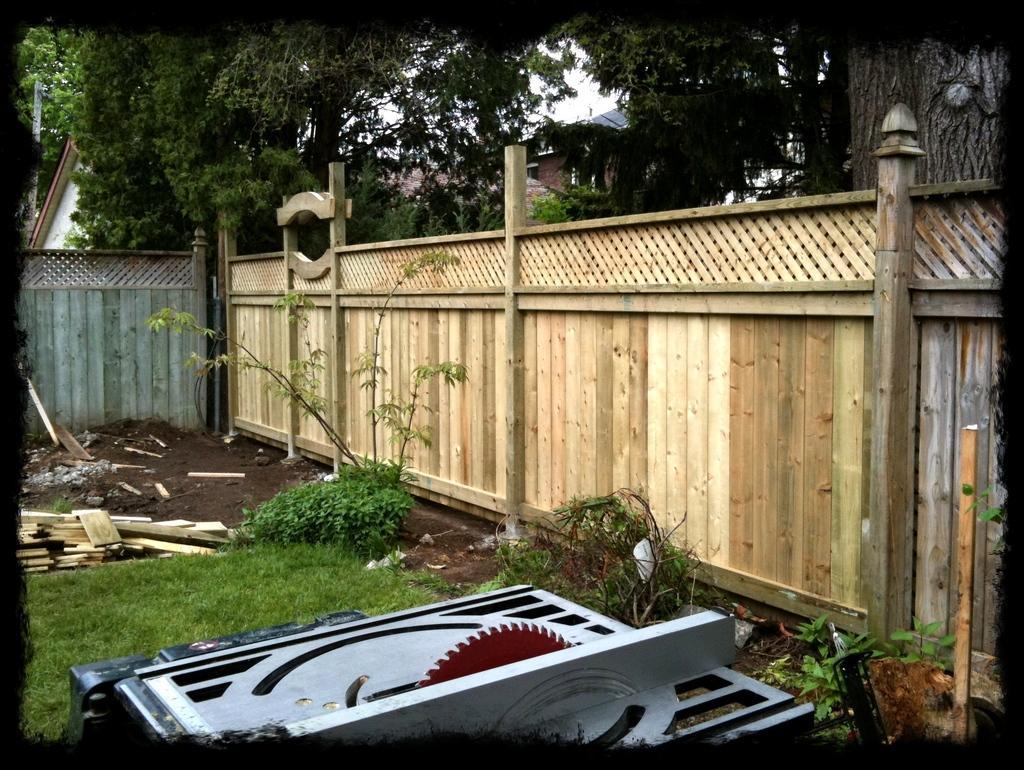How would you summarize this image in a sentence or two? In this picture I can see a wooden fencing and also we can see some objects are placed on the grass, behind we can see some trees, houses. 